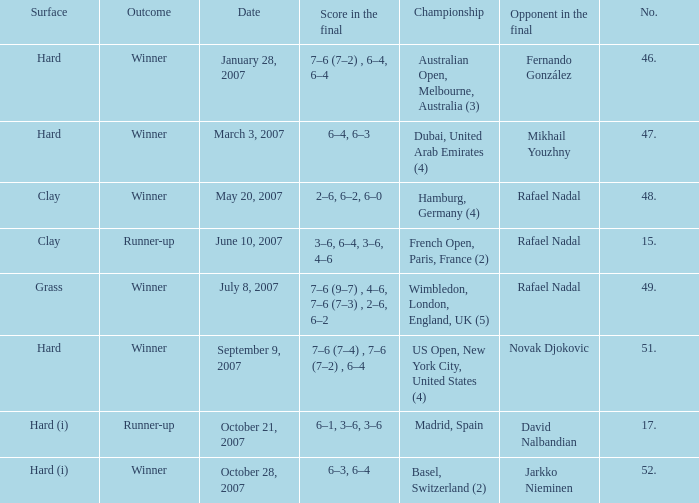Where the outcome is Winner and surface is Hard (i), what is the No.? 52.0. 